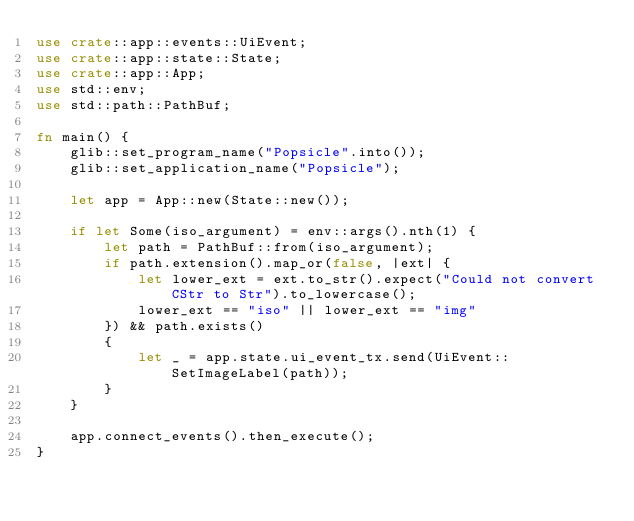<code> <loc_0><loc_0><loc_500><loc_500><_Rust_>use crate::app::events::UiEvent;
use crate::app::state::State;
use crate::app::App;
use std::env;
use std::path::PathBuf;

fn main() {
    glib::set_program_name("Popsicle".into());
    glib::set_application_name("Popsicle");

    let app = App::new(State::new());

    if let Some(iso_argument) = env::args().nth(1) {
        let path = PathBuf::from(iso_argument);
        if path.extension().map_or(false, |ext| {
            let lower_ext = ext.to_str().expect("Could not convert CStr to Str").to_lowercase();
            lower_ext == "iso" || lower_ext == "img"
        }) && path.exists()
        {
            let _ = app.state.ui_event_tx.send(UiEvent::SetImageLabel(path));
        }
    }

    app.connect_events().then_execute();
}
</code> 